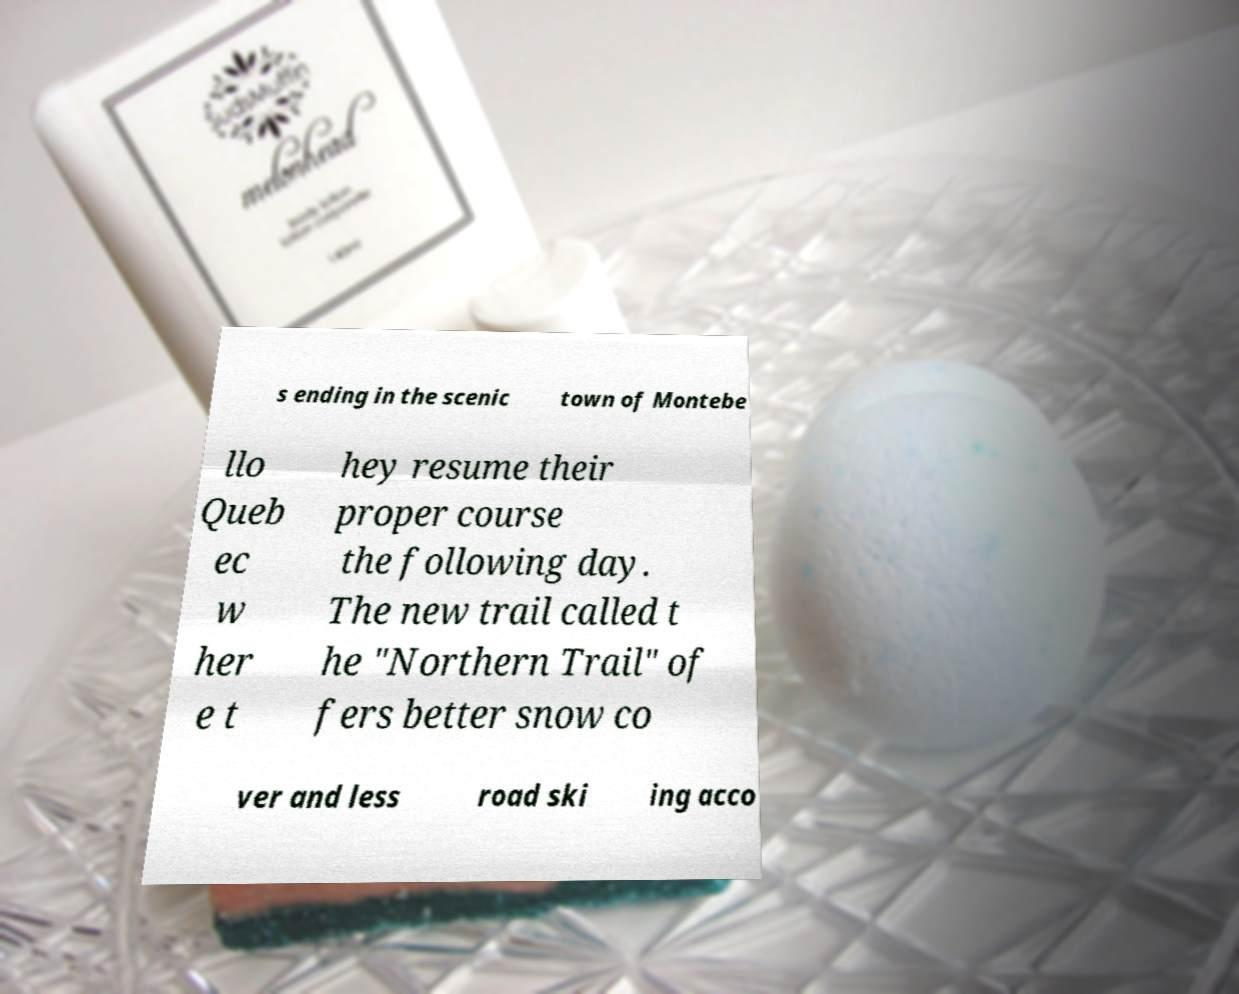Can you read and provide the text displayed in the image?This photo seems to have some interesting text. Can you extract and type it out for me? s ending in the scenic town of Montebe llo Queb ec w her e t hey resume their proper course the following day. The new trail called t he "Northern Trail" of fers better snow co ver and less road ski ing acco 